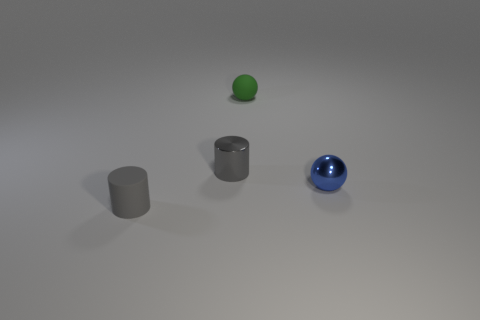There is another sphere that is the same size as the blue sphere; what is its color?
Your response must be concise. Green. Is there a blue thing made of the same material as the green thing?
Ensure brevity in your answer.  No. Do the object that is on the right side of the tiny green matte thing and the tiny gray thing on the left side of the small gray shiny cylinder have the same material?
Your answer should be compact. No. What number of small metal things are there?
Offer a very short reply. 2. There is a tiny gray object behind the tiny metallic sphere; what shape is it?
Your response must be concise. Cylinder. How many other objects are there of the same size as the blue sphere?
Ensure brevity in your answer.  3. Do the tiny gray matte object that is in front of the small green object and the small matte thing that is behind the rubber cylinder have the same shape?
Offer a terse response. No. There is a tiny green rubber sphere; what number of blue metal things are on the left side of it?
Provide a succinct answer. 0. The metal thing that is to the left of the tiny blue shiny ball is what color?
Offer a terse response. Gray. There is another thing that is the same shape as the small green thing; what color is it?
Your answer should be very brief. Blue. 